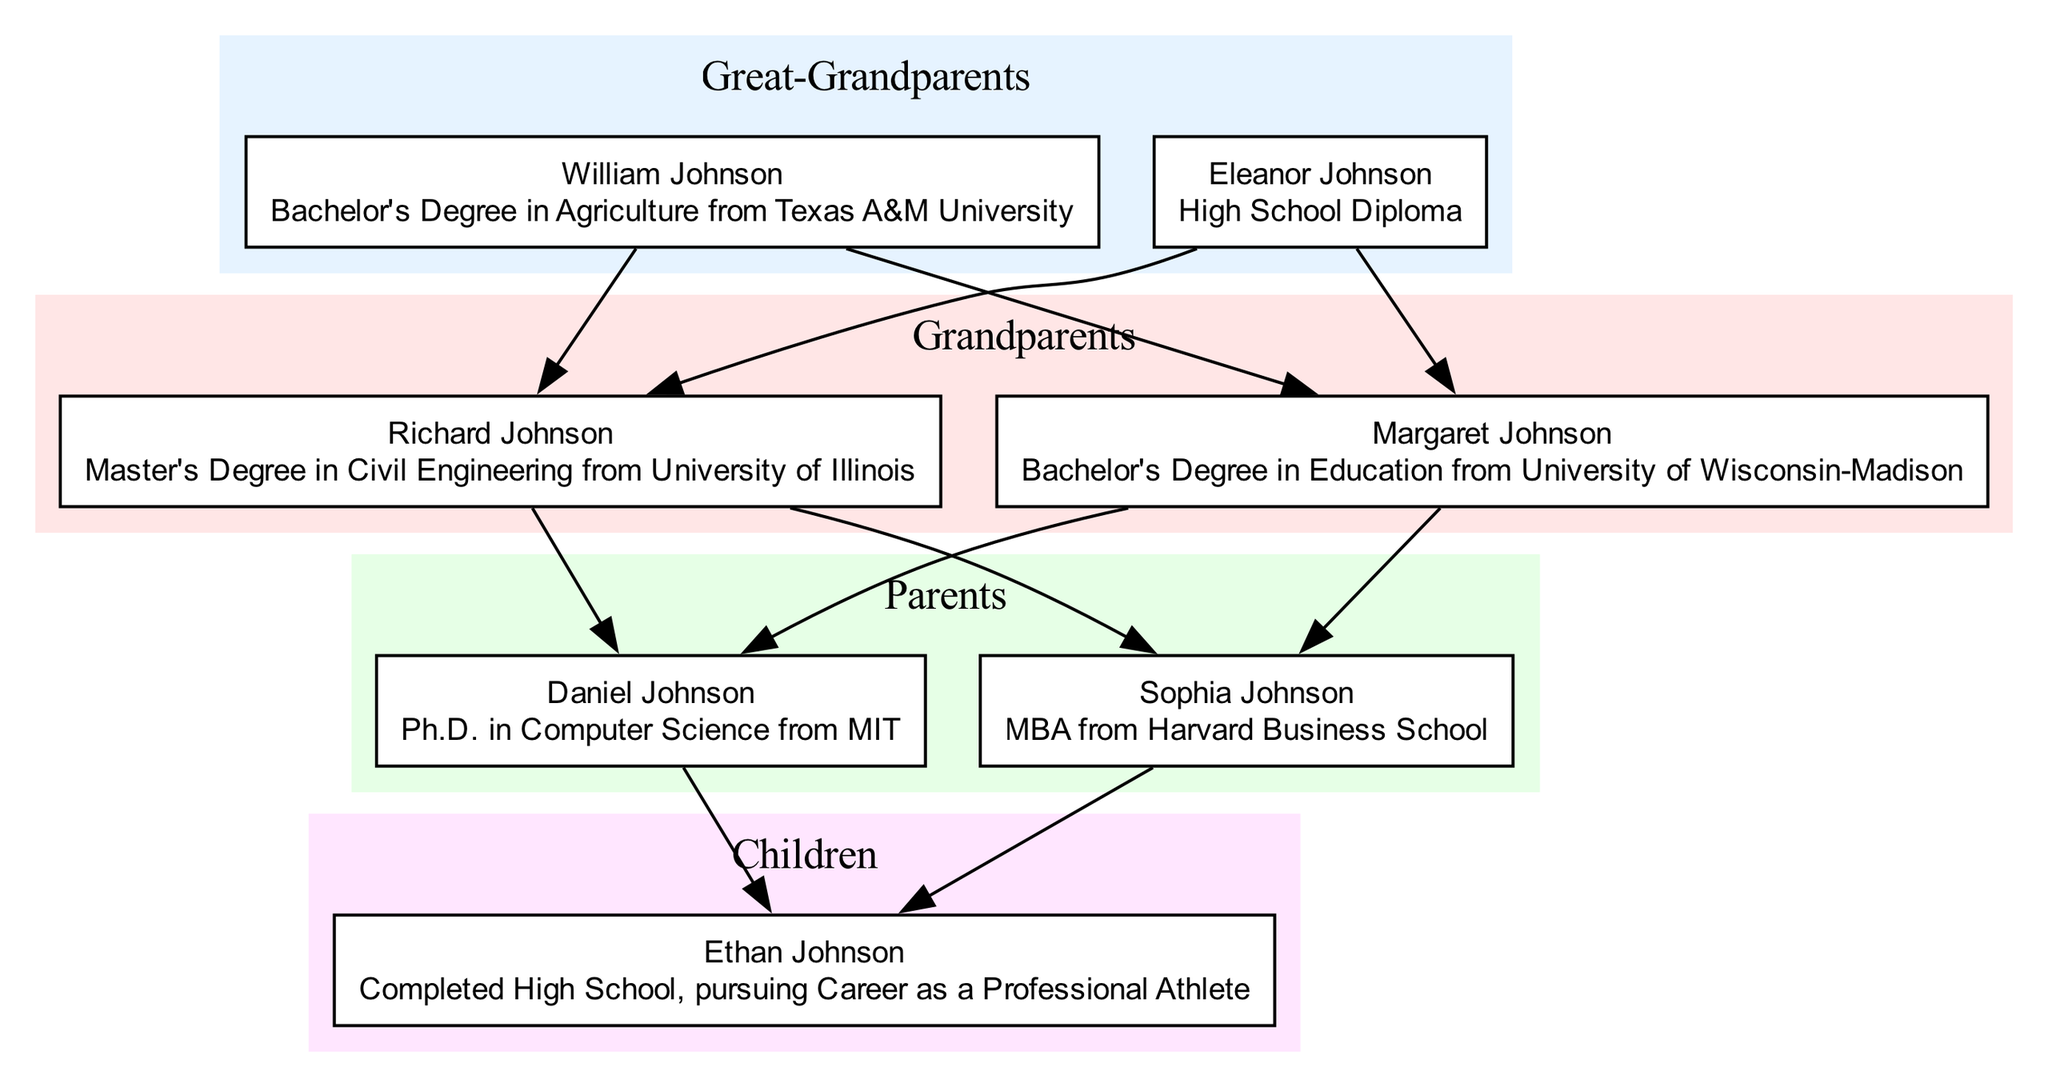What academic achievement did William Johnson accomplish? William Johnson, as listed in the "Great-Grandparents" generation, earned a Bachelor's Degree in Agriculture from Texas A&M University. This information is directly stated next to his name in the diagram.
Answer: Bachelor's Degree in Agriculture from Texas A&M University How many family members achieved a Master's Degree or higher? To determine the number of members with a Master's Degree or higher, we look at the achievements of each generation. Richard Johnson has a Master's Degree, Daniel Johnson has a Ph.D., and Sophia Johnson has an MBA. Counting these, there are three members with advanced degrees.
Answer: 3 Who is the only child listed in the diagram? The "Children" generation contains only one family member, Ethan Johnson. This can be identified by examining the members within the "Children" section of the diagram.
Answer: Ethan Johnson Which family member has an achievement in Education? In the "Grandparents" generation, Margaret Johnson received a Bachelor's Degree in Education from the University of Wisconsin-Madison. This achievement is noted next to her name in the diagram, confirming that she is the one with this specific accomplishment.
Answer: Margaret Johnson Which generation has the highest educational qualification? The "Parents" generation contains Daniel Johnson, who holds a Ph.D. in Computer Science from MIT, and Sophia Johnson, who has an MBA from Harvard Business School. The Ph.D. represents the highest level of educational qualification, making the "Parents" generation the one with the highest achievement overall.
Answer: Parents How many generations are represented in the diagram? The diagram lays out four distinct generations: Great-Grandparents, Grandparents, Parents, and Children. Counting these generational labels provides the total of four generations depicted in this family tree.
Answer: 4 Which family member is pursuing a career as a professional athlete? In the "Children" generation, Ethan Johnson is noted as having completed high school and is pursuing a career as a professional athlete. This information is clearly stated in the diagram next to his name.
Answer: Ethan Johnson What is the achievement of Sophia Johnson? Sophia Johnson has an MBA from Harvard Business School, as stated in the "Parents" generation section of the diagram. This specific degree is connected directly to her name, clearly outlining her educational accomplishment.
Answer: MBA from Harvard Business School 